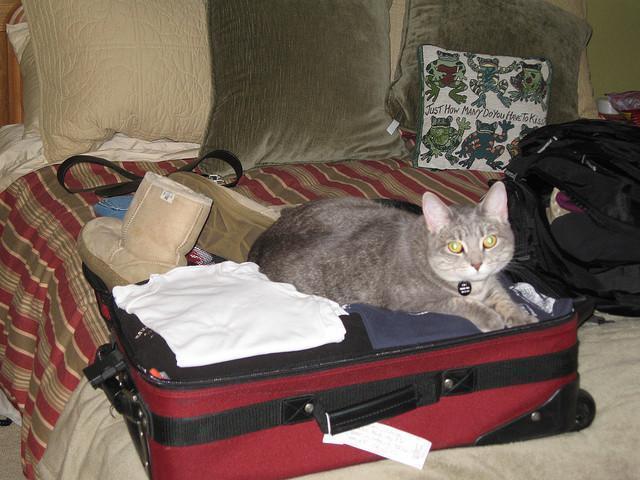How many people are in the pic?
Give a very brief answer. 0. 